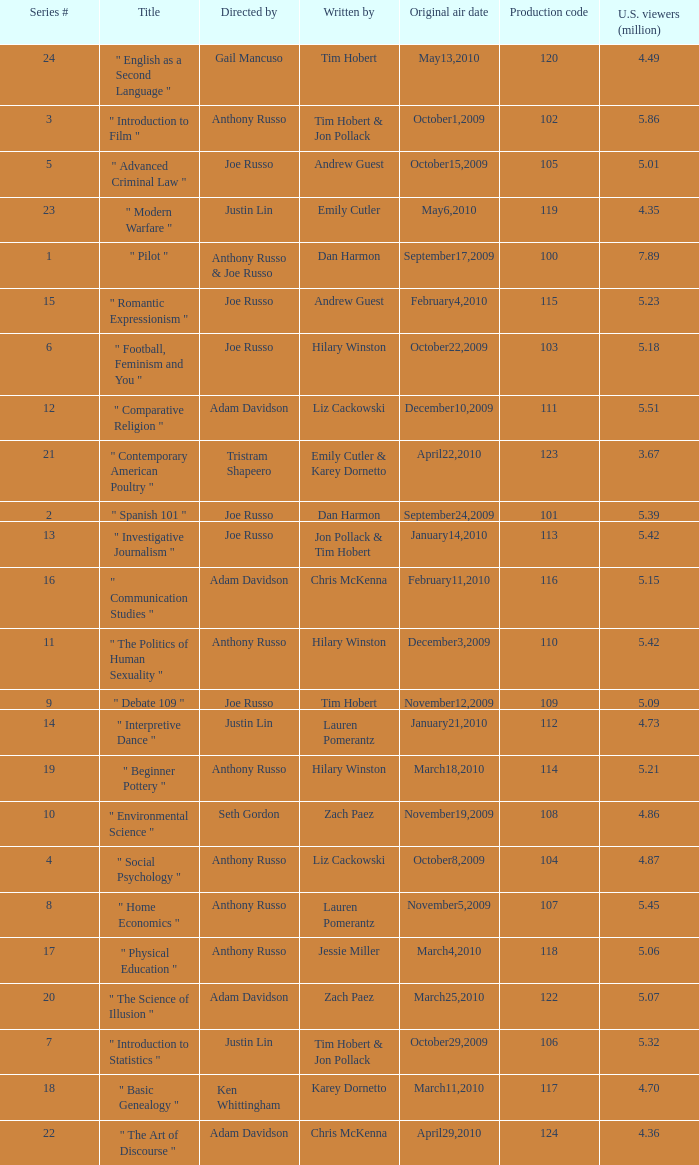What is the original air date when the u.s. viewers in millions was 5.39? September24,2009. 